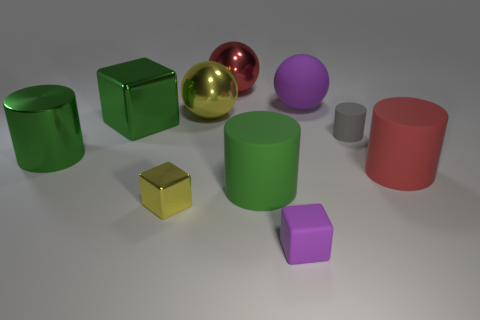Subtract all green cylinders. How many were subtracted if there are1green cylinders left? 1 Subtract 1 spheres. How many spheres are left? 2 Subtract all yellow cylinders. Subtract all gray balls. How many cylinders are left? 4 Subtract all balls. How many objects are left? 7 Subtract all large red matte things. Subtract all big red rubber cylinders. How many objects are left? 8 Add 5 green matte cylinders. How many green matte cylinders are left? 6 Add 7 tiny gray metallic cylinders. How many tiny gray metallic cylinders exist? 7 Subtract 1 yellow spheres. How many objects are left? 9 